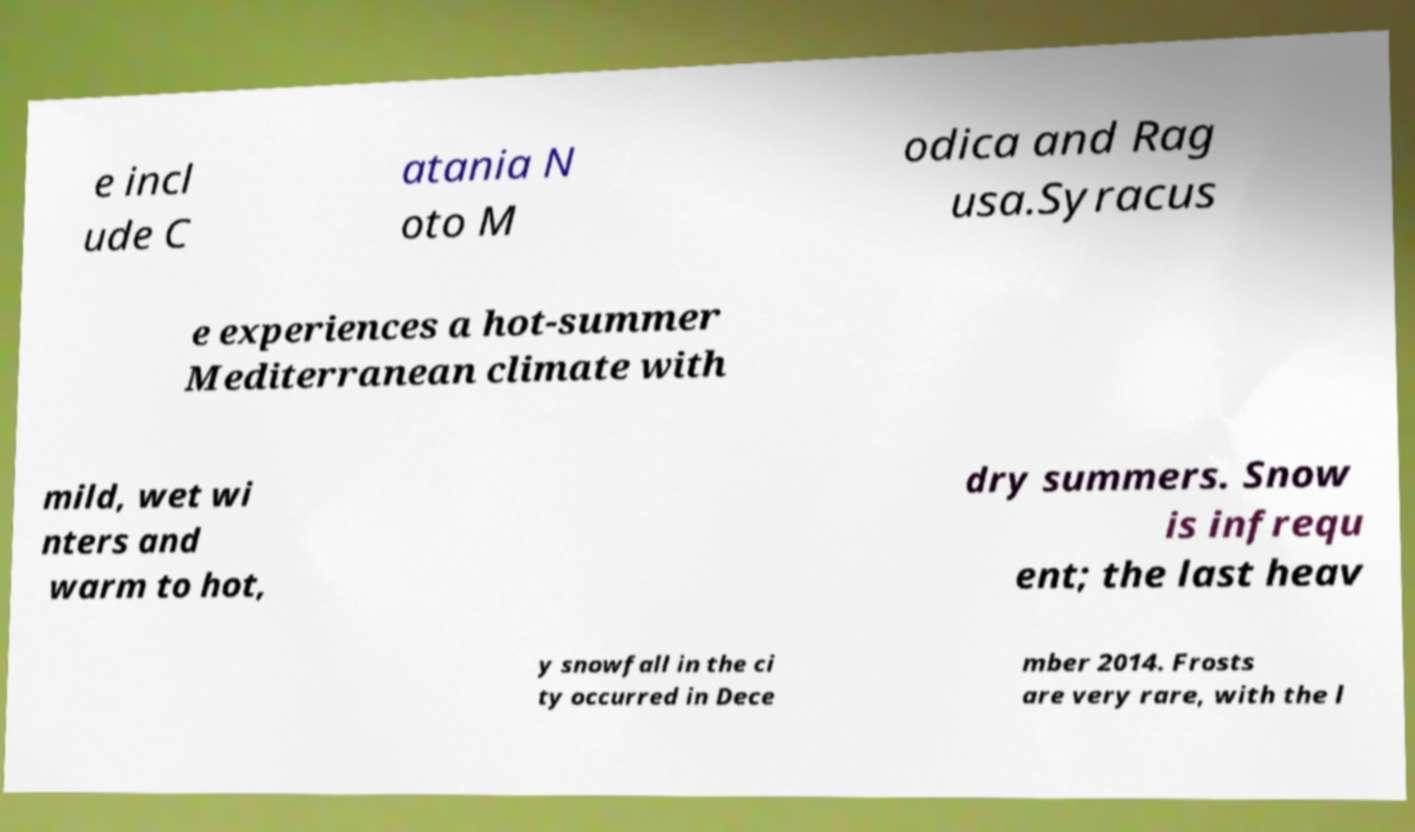Please read and relay the text visible in this image. What does it say? e incl ude C atania N oto M odica and Rag usa.Syracus e experiences a hot-summer Mediterranean climate with mild, wet wi nters and warm to hot, dry summers. Snow is infrequ ent; the last heav y snowfall in the ci ty occurred in Dece mber 2014. Frosts are very rare, with the l 